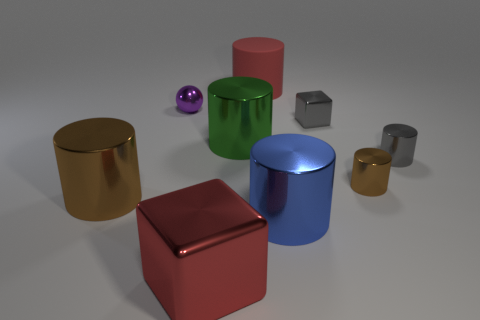Subtract all cylinders. How many objects are left? 3 Subtract 1 blocks. How many blocks are left? 1 Subtract all metallic cylinders. How many cylinders are left? 1 Subtract all green cubes. How many blue spheres are left? 0 Subtract all red blocks. How many blocks are left? 1 Subtract 0 purple cylinders. How many objects are left? 9 Subtract all yellow cylinders. Subtract all green balls. How many cylinders are left? 6 Subtract all large brown shiny balls. Subtract all tiny metal things. How many objects are left? 5 Add 4 small brown things. How many small brown things are left? 5 Add 3 big cyan matte cylinders. How many big cyan matte cylinders exist? 3 